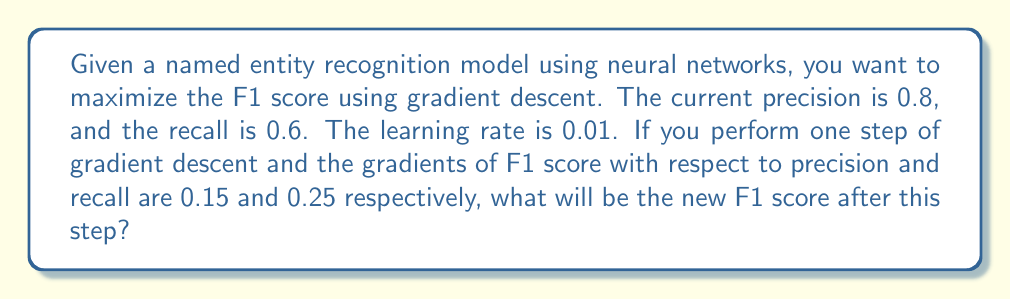Provide a solution to this math problem. Let's approach this step-by-step:

1) First, recall the formula for F1 score:
   $$F1 = \frac{2 \times precision \times recall}{precision + recall}$$

2) Calculate the current F1 score:
   $$F1 = \frac{2 \times 0.8 \times 0.6}{0.8 + 0.6} = \frac{0.96}{1.4} \approx 0.6857$$

3) In gradient descent, we update parameters in the direction of the gradient:
   $$new\_precision = precision + learning\_rate \times \frac{\partial F1}{\partial precision}$$
   $$new\_recall = recall + learning\_rate \times \frac{\partial F1}{\partial recall}$$

4) Calculate new precision and recall:
   $$new\_precision = 0.8 + 0.01 \times 0.15 = 0.8015$$
   $$new\_recall = 0.6 + 0.01 \times 0.25 = 0.6025$$

5) Calculate the new F1 score using these updated values:
   $$new\_F1 = \frac{2 \times 0.8015 \times 0.6025}{0.8015 + 0.6025}$$

6) Simplify:
   $$new\_F1 = \frac{0.9660165}{1.404} \approx 0.6880$$

Therefore, after one step of gradient descent, the new F1 score is approximately 0.6880.
Answer: 0.6880 (rounded to 4 decimal places) 